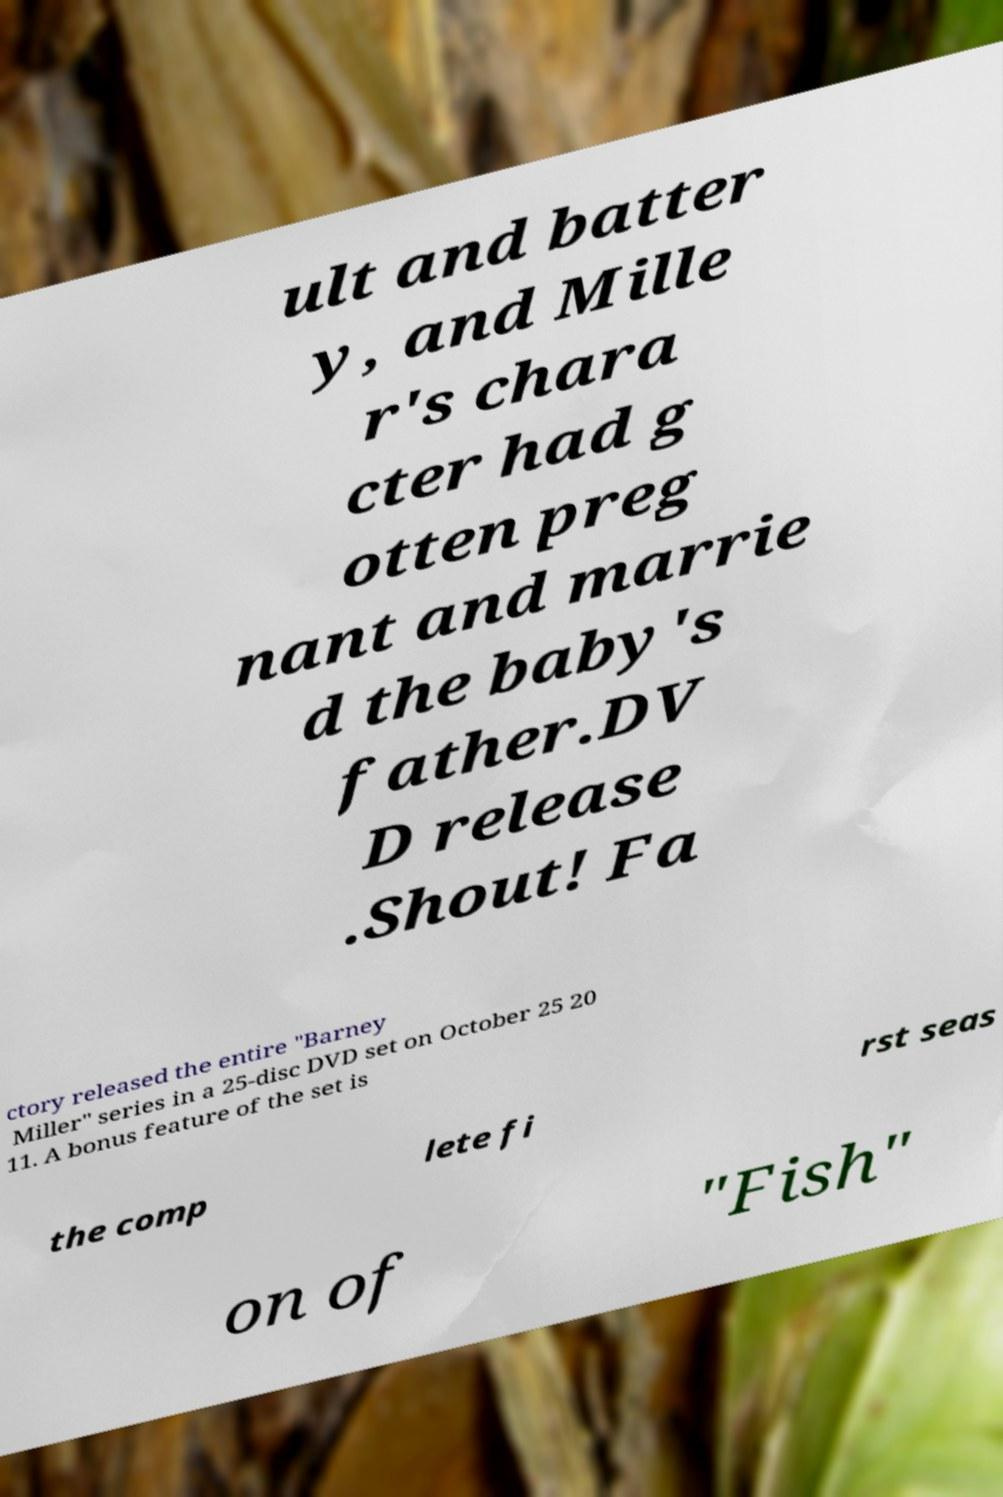Could you assist in decoding the text presented in this image and type it out clearly? ult and batter y, and Mille r's chara cter had g otten preg nant and marrie d the baby's father.DV D release .Shout! Fa ctory released the entire "Barney Miller" series in a 25-disc DVD set on October 25 20 11. A bonus feature of the set is the comp lete fi rst seas on of "Fish" 